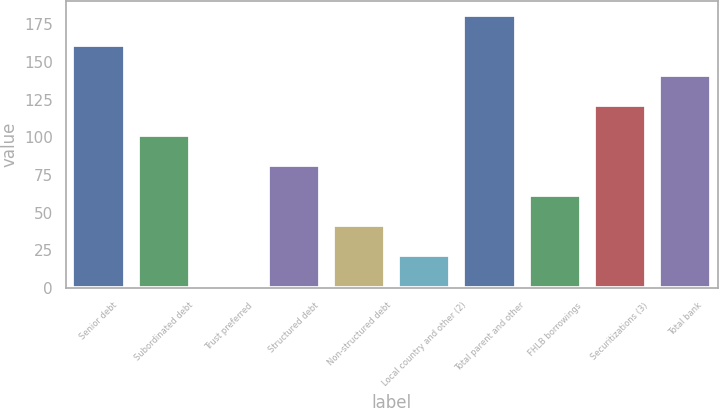Convert chart to OTSL. <chart><loc_0><loc_0><loc_500><loc_500><bar_chart><fcel>Senior debt<fcel>Subordinated debt<fcel>Trust preferred<fcel>Structured debt<fcel>Non-structured debt<fcel>Local country and other (2)<fcel>Total parent and other<fcel>FHLB borrowings<fcel>Securitizations (3)<fcel>Total bank<nl><fcel>161.38<fcel>101.5<fcel>1.7<fcel>81.54<fcel>41.62<fcel>21.66<fcel>181.34<fcel>61.58<fcel>121.46<fcel>141.42<nl></chart> 